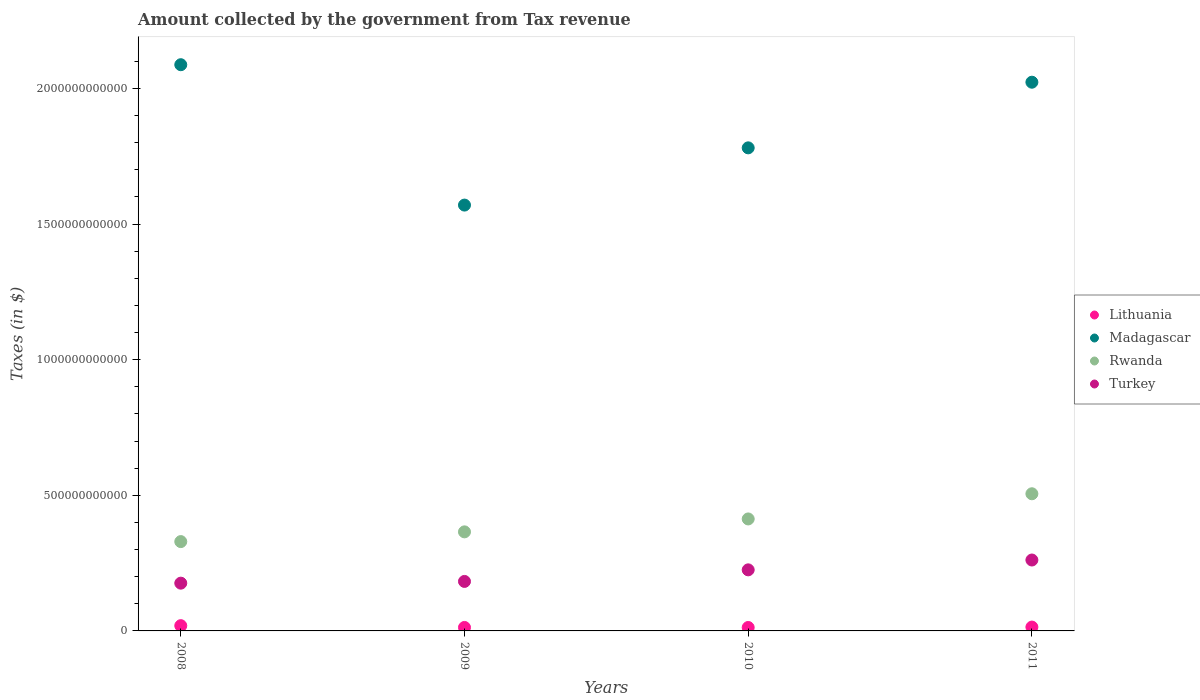How many different coloured dotlines are there?
Offer a very short reply. 4. Is the number of dotlines equal to the number of legend labels?
Provide a succinct answer. Yes. What is the amount collected by the government from tax revenue in Lithuania in 2009?
Provide a succinct answer. 1.28e+1. Across all years, what is the maximum amount collected by the government from tax revenue in Turkey?
Keep it short and to the point. 2.61e+11. Across all years, what is the minimum amount collected by the government from tax revenue in Madagascar?
Provide a succinct answer. 1.57e+12. In which year was the amount collected by the government from tax revenue in Turkey minimum?
Provide a succinct answer. 2008. What is the total amount collected by the government from tax revenue in Rwanda in the graph?
Your response must be concise. 1.61e+12. What is the difference between the amount collected by the government from tax revenue in Madagascar in 2009 and that in 2011?
Provide a short and direct response. -4.53e+11. What is the difference between the amount collected by the government from tax revenue in Turkey in 2011 and the amount collected by the government from tax revenue in Lithuania in 2008?
Make the answer very short. 2.42e+11. What is the average amount collected by the government from tax revenue in Madagascar per year?
Make the answer very short. 1.87e+12. In the year 2009, what is the difference between the amount collected by the government from tax revenue in Madagascar and amount collected by the government from tax revenue in Turkey?
Give a very brief answer. 1.39e+12. In how many years, is the amount collected by the government from tax revenue in Turkey greater than 1500000000000 $?
Offer a very short reply. 0. What is the ratio of the amount collected by the government from tax revenue in Turkey in 2010 to that in 2011?
Your answer should be very brief. 0.86. What is the difference between the highest and the second highest amount collected by the government from tax revenue in Madagascar?
Ensure brevity in your answer.  6.45e+1. What is the difference between the highest and the lowest amount collected by the government from tax revenue in Turkey?
Provide a short and direct response. 8.53e+1. In how many years, is the amount collected by the government from tax revenue in Turkey greater than the average amount collected by the government from tax revenue in Turkey taken over all years?
Give a very brief answer. 2. Is it the case that in every year, the sum of the amount collected by the government from tax revenue in Turkey and amount collected by the government from tax revenue in Lithuania  is greater than the sum of amount collected by the government from tax revenue in Madagascar and amount collected by the government from tax revenue in Rwanda?
Ensure brevity in your answer.  No. Is it the case that in every year, the sum of the amount collected by the government from tax revenue in Turkey and amount collected by the government from tax revenue in Rwanda  is greater than the amount collected by the government from tax revenue in Madagascar?
Your answer should be very brief. No. Does the amount collected by the government from tax revenue in Lithuania monotonically increase over the years?
Ensure brevity in your answer.  No. Is the amount collected by the government from tax revenue in Rwanda strictly less than the amount collected by the government from tax revenue in Madagascar over the years?
Provide a short and direct response. Yes. How many years are there in the graph?
Make the answer very short. 4. What is the difference between two consecutive major ticks on the Y-axis?
Offer a terse response. 5.00e+11. Does the graph contain any zero values?
Ensure brevity in your answer.  No. How many legend labels are there?
Provide a succinct answer. 4. What is the title of the graph?
Your answer should be very brief. Amount collected by the government from Tax revenue. What is the label or title of the Y-axis?
Offer a terse response. Taxes (in $). What is the Taxes (in $) in Lithuania in 2008?
Keep it short and to the point. 1.94e+1. What is the Taxes (in $) in Madagascar in 2008?
Offer a terse response. 2.09e+12. What is the Taxes (in $) in Rwanda in 2008?
Your response must be concise. 3.29e+11. What is the Taxes (in $) of Turkey in 2008?
Keep it short and to the point. 1.76e+11. What is the Taxes (in $) in Lithuania in 2009?
Your response must be concise. 1.28e+1. What is the Taxes (in $) in Madagascar in 2009?
Offer a terse response. 1.57e+12. What is the Taxes (in $) of Rwanda in 2009?
Ensure brevity in your answer.  3.65e+11. What is the Taxes (in $) of Turkey in 2009?
Your response must be concise. 1.82e+11. What is the Taxes (in $) in Lithuania in 2010?
Offer a very short reply. 1.26e+1. What is the Taxes (in $) of Madagascar in 2010?
Offer a very short reply. 1.78e+12. What is the Taxes (in $) of Rwanda in 2010?
Make the answer very short. 4.13e+11. What is the Taxes (in $) of Turkey in 2010?
Your answer should be compact. 2.25e+11. What is the Taxes (in $) in Lithuania in 2011?
Keep it short and to the point. 1.42e+1. What is the Taxes (in $) in Madagascar in 2011?
Offer a very short reply. 2.02e+12. What is the Taxes (in $) in Rwanda in 2011?
Provide a succinct answer. 5.06e+11. What is the Taxes (in $) of Turkey in 2011?
Give a very brief answer. 2.61e+11. Across all years, what is the maximum Taxes (in $) in Lithuania?
Offer a terse response. 1.94e+1. Across all years, what is the maximum Taxes (in $) in Madagascar?
Your response must be concise. 2.09e+12. Across all years, what is the maximum Taxes (in $) in Rwanda?
Your answer should be very brief. 5.06e+11. Across all years, what is the maximum Taxes (in $) of Turkey?
Ensure brevity in your answer.  2.61e+11. Across all years, what is the minimum Taxes (in $) of Lithuania?
Provide a succinct answer. 1.26e+1. Across all years, what is the minimum Taxes (in $) in Madagascar?
Your response must be concise. 1.57e+12. Across all years, what is the minimum Taxes (in $) in Rwanda?
Offer a very short reply. 3.29e+11. Across all years, what is the minimum Taxes (in $) in Turkey?
Your answer should be very brief. 1.76e+11. What is the total Taxes (in $) of Lithuania in the graph?
Provide a succinct answer. 5.90e+1. What is the total Taxes (in $) in Madagascar in the graph?
Your answer should be very brief. 7.46e+12. What is the total Taxes (in $) in Rwanda in the graph?
Offer a very short reply. 1.61e+12. What is the total Taxes (in $) in Turkey in the graph?
Your response must be concise. 8.45e+11. What is the difference between the Taxes (in $) of Lithuania in 2008 and that in 2009?
Offer a very short reply. 6.59e+09. What is the difference between the Taxes (in $) of Madagascar in 2008 and that in 2009?
Ensure brevity in your answer.  5.17e+11. What is the difference between the Taxes (in $) in Rwanda in 2008 and that in 2009?
Provide a succinct answer. -3.59e+1. What is the difference between the Taxes (in $) in Turkey in 2008 and that in 2009?
Your answer should be very brief. -6.43e+09. What is the difference between the Taxes (in $) in Lithuania in 2008 and that in 2010?
Keep it short and to the point. 6.74e+09. What is the difference between the Taxes (in $) in Madagascar in 2008 and that in 2010?
Give a very brief answer. 3.06e+11. What is the difference between the Taxes (in $) in Rwanda in 2008 and that in 2010?
Give a very brief answer. -8.35e+1. What is the difference between the Taxes (in $) of Turkey in 2008 and that in 2010?
Your answer should be compact. -4.91e+1. What is the difference between the Taxes (in $) in Lithuania in 2008 and that in 2011?
Provide a short and direct response. 5.20e+09. What is the difference between the Taxes (in $) of Madagascar in 2008 and that in 2011?
Offer a very short reply. 6.45e+1. What is the difference between the Taxes (in $) of Rwanda in 2008 and that in 2011?
Your response must be concise. -1.76e+11. What is the difference between the Taxes (in $) of Turkey in 2008 and that in 2011?
Give a very brief answer. -8.53e+1. What is the difference between the Taxes (in $) in Lithuania in 2009 and that in 2010?
Your response must be concise. 1.54e+08. What is the difference between the Taxes (in $) in Madagascar in 2009 and that in 2010?
Your answer should be very brief. -2.11e+11. What is the difference between the Taxes (in $) in Rwanda in 2009 and that in 2010?
Offer a terse response. -4.76e+1. What is the difference between the Taxes (in $) in Turkey in 2009 and that in 2010?
Provide a short and direct response. -4.26e+1. What is the difference between the Taxes (in $) of Lithuania in 2009 and that in 2011?
Offer a very short reply. -1.38e+09. What is the difference between the Taxes (in $) of Madagascar in 2009 and that in 2011?
Ensure brevity in your answer.  -4.53e+11. What is the difference between the Taxes (in $) of Rwanda in 2009 and that in 2011?
Keep it short and to the point. -1.40e+11. What is the difference between the Taxes (in $) of Turkey in 2009 and that in 2011?
Your answer should be very brief. -7.89e+1. What is the difference between the Taxes (in $) in Lithuania in 2010 and that in 2011?
Provide a succinct answer. -1.54e+09. What is the difference between the Taxes (in $) of Madagascar in 2010 and that in 2011?
Keep it short and to the point. -2.42e+11. What is the difference between the Taxes (in $) in Rwanda in 2010 and that in 2011?
Provide a succinct answer. -9.28e+1. What is the difference between the Taxes (in $) in Turkey in 2010 and that in 2011?
Provide a short and direct response. -3.63e+1. What is the difference between the Taxes (in $) of Lithuania in 2008 and the Taxes (in $) of Madagascar in 2009?
Offer a very short reply. -1.55e+12. What is the difference between the Taxes (in $) in Lithuania in 2008 and the Taxes (in $) in Rwanda in 2009?
Give a very brief answer. -3.46e+11. What is the difference between the Taxes (in $) in Lithuania in 2008 and the Taxes (in $) in Turkey in 2009?
Your answer should be very brief. -1.63e+11. What is the difference between the Taxes (in $) in Madagascar in 2008 and the Taxes (in $) in Rwanda in 2009?
Keep it short and to the point. 1.72e+12. What is the difference between the Taxes (in $) in Madagascar in 2008 and the Taxes (in $) in Turkey in 2009?
Your response must be concise. 1.90e+12. What is the difference between the Taxes (in $) of Rwanda in 2008 and the Taxes (in $) of Turkey in 2009?
Give a very brief answer. 1.47e+11. What is the difference between the Taxes (in $) of Lithuania in 2008 and the Taxes (in $) of Madagascar in 2010?
Ensure brevity in your answer.  -1.76e+12. What is the difference between the Taxes (in $) in Lithuania in 2008 and the Taxes (in $) in Rwanda in 2010?
Keep it short and to the point. -3.93e+11. What is the difference between the Taxes (in $) of Lithuania in 2008 and the Taxes (in $) of Turkey in 2010?
Keep it short and to the point. -2.06e+11. What is the difference between the Taxes (in $) of Madagascar in 2008 and the Taxes (in $) of Rwanda in 2010?
Provide a succinct answer. 1.67e+12. What is the difference between the Taxes (in $) of Madagascar in 2008 and the Taxes (in $) of Turkey in 2010?
Keep it short and to the point. 1.86e+12. What is the difference between the Taxes (in $) in Rwanda in 2008 and the Taxes (in $) in Turkey in 2010?
Provide a succinct answer. 1.04e+11. What is the difference between the Taxes (in $) in Lithuania in 2008 and the Taxes (in $) in Madagascar in 2011?
Offer a very short reply. -2.00e+12. What is the difference between the Taxes (in $) of Lithuania in 2008 and the Taxes (in $) of Rwanda in 2011?
Give a very brief answer. -4.86e+11. What is the difference between the Taxes (in $) of Lithuania in 2008 and the Taxes (in $) of Turkey in 2011?
Offer a terse response. -2.42e+11. What is the difference between the Taxes (in $) of Madagascar in 2008 and the Taxes (in $) of Rwanda in 2011?
Your response must be concise. 1.58e+12. What is the difference between the Taxes (in $) of Madagascar in 2008 and the Taxes (in $) of Turkey in 2011?
Provide a succinct answer. 1.83e+12. What is the difference between the Taxes (in $) in Rwanda in 2008 and the Taxes (in $) in Turkey in 2011?
Offer a very short reply. 6.79e+1. What is the difference between the Taxes (in $) of Lithuania in 2009 and the Taxes (in $) of Madagascar in 2010?
Your answer should be very brief. -1.77e+12. What is the difference between the Taxes (in $) in Lithuania in 2009 and the Taxes (in $) in Rwanda in 2010?
Provide a succinct answer. -4.00e+11. What is the difference between the Taxes (in $) of Lithuania in 2009 and the Taxes (in $) of Turkey in 2010?
Provide a succinct answer. -2.12e+11. What is the difference between the Taxes (in $) of Madagascar in 2009 and the Taxes (in $) of Rwanda in 2010?
Provide a short and direct response. 1.16e+12. What is the difference between the Taxes (in $) of Madagascar in 2009 and the Taxes (in $) of Turkey in 2010?
Provide a short and direct response. 1.34e+12. What is the difference between the Taxes (in $) in Rwanda in 2009 and the Taxes (in $) in Turkey in 2010?
Offer a terse response. 1.40e+11. What is the difference between the Taxes (in $) of Lithuania in 2009 and the Taxes (in $) of Madagascar in 2011?
Provide a succinct answer. -2.01e+12. What is the difference between the Taxes (in $) of Lithuania in 2009 and the Taxes (in $) of Rwanda in 2011?
Offer a very short reply. -4.93e+11. What is the difference between the Taxes (in $) in Lithuania in 2009 and the Taxes (in $) in Turkey in 2011?
Offer a very short reply. -2.49e+11. What is the difference between the Taxes (in $) of Madagascar in 2009 and the Taxes (in $) of Rwanda in 2011?
Your answer should be very brief. 1.06e+12. What is the difference between the Taxes (in $) of Madagascar in 2009 and the Taxes (in $) of Turkey in 2011?
Your answer should be compact. 1.31e+12. What is the difference between the Taxes (in $) of Rwanda in 2009 and the Taxes (in $) of Turkey in 2011?
Your answer should be compact. 1.04e+11. What is the difference between the Taxes (in $) of Lithuania in 2010 and the Taxes (in $) of Madagascar in 2011?
Your response must be concise. -2.01e+12. What is the difference between the Taxes (in $) in Lithuania in 2010 and the Taxes (in $) in Rwanda in 2011?
Keep it short and to the point. -4.93e+11. What is the difference between the Taxes (in $) in Lithuania in 2010 and the Taxes (in $) in Turkey in 2011?
Provide a succinct answer. -2.49e+11. What is the difference between the Taxes (in $) of Madagascar in 2010 and the Taxes (in $) of Rwanda in 2011?
Provide a succinct answer. 1.28e+12. What is the difference between the Taxes (in $) of Madagascar in 2010 and the Taxes (in $) of Turkey in 2011?
Offer a terse response. 1.52e+12. What is the difference between the Taxes (in $) in Rwanda in 2010 and the Taxes (in $) in Turkey in 2011?
Ensure brevity in your answer.  1.51e+11. What is the average Taxes (in $) in Lithuania per year?
Give a very brief answer. 1.47e+1. What is the average Taxes (in $) in Madagascar per year?
Keep it short and to the point. 1.87e+12. What is the average Taxes (in $) in Rwanda per year?
Provide a succinct answer. 4.03e+11. What is the average Taxes (in $) of Turkey per year?
Give a very brief answer. 2.11e+11. In the year 2008, what is the difference between the Taxes (in $) in Lithuania and Taxes (in $) in Madagascar?
Your response must be concise. -2.07e+12. In the year 2008, what is the difference between the Taxes (in $) of Lithuania and Taxes (in $) of Rwanda?
Make the answer very short. -3.10e+11. In the year 2008, what is the difference between the Taxes (in $) of Lithuania and Taxes (in $) of Turkey?
Provide a short and direct response. -1.57e+11. In the year 2008, what is the difference between the Taxes (in $) in Madagascar and Taxes (in $) in Rwanda?
Offer a terse response. 1.76e+12. In the year 2008, what is the difference between the Taxes (in $) in Madagascar and Taxes (in $) in Turkey?
Ensure brevity in your answer.  1.91e+12. In the year 2008, what is the difference between the Taxes (in $) of Rwanda and Taxes (in $) of Turkey?
Keep it short and to the point. 1.53e+11. In the year 2009, what is the difference between the Taxes (in $) in Lithuania and Taxes (in $) in Madagascar?
Provide a short and direct response. -1.56e+12. In the year 2009, what is the difference between the Taxes (in $) of Lithuania and Taxes (in $) of Rwanda?
Your answer should be compact. -3.52e+11. In the year 2009, what is the difference between the Taxes (in $) in Lithuania and Taxes (in $) in Turkey?
Offer a terse response. -1.70e+11. In the year 2009, what is the difference between the Taxes (in $) of Madagascar and Taxes (in $) of Rwanda?
Make the answer very short. 1.20e+12. In the year 2009, what is the difference between the Taxes (in $) of Madagascar and Taxes (in $) of Turkey?
Your response must be concise. 1.39e+12. In the year 2009, what is the difference between the Taxes (in $) of Rwanda and Taxes (in $) of Turkey?
Make the answer very short. 1.83e+11. In the year 2010, what is the difference between the Taxes (in $) in Lithuania and Taxes (in $) in Madagascar?
Provide a short and direct response. -1.77e+12. In the year 2010, what is the difference between the Taxes (in $) of Lithuania and Taxes (in $) of Rwanda?
Offer a very short reply. -4.00e+11. In the year 2010, what is the difference between the Taxes (in $) of Lithuania and Taxes (in $) of Turkey?
Keep it short and to the point. -2.12e+11. In the year 2010, what is the difference between the Taxes (in $) in Madagascar and Taxes (in $) in Rwanda?
Offer a very short reply. 1.37e+12. In the year 2010, what is the difference between the Taxes (in $) of Madagascar and Taxes (in $) of Turkey?
Keep it short and to the point. 1.56e+12. In the year 2010, what is the difference between the Taxes (in $) of Rwanda and Taxes (in $) of Turkey?
Your answer should be very brief. 1.88e+11. In the year 2011, what is the difference between the Taxes (in $) of Lithuania and Taxes (in $) of Madagascar?
Your response must be concise. -2.01e+12. In the year 2011, what is the difference between the Taxes (in $) of Lithuania and Taxes (in $) of Rwanda?
Keep it short and to the point. -4.91e+11. In the year 2011, what is the difference between the Taxes (in $) of Lithuania and Taxes (in $) of Turkey?
Keep it short and to the point. -2.47e+11. In the year 2011, what is the difference between the Taxes (in $) of Madagascar and Taxes (in $) of Rwanda?
Your answer should be very brief. 1.52e+12. In the year 2011, what is the difference between the Taxes (in $) in Madagascar and Taxes (in $) in Turkey?
Keep it short and to the point. 1.76e+12. In the year 2011, what is the difference between the Taxes (in $) of Rwanda and Taxes (in $) of Turkey?
Your answer should be compact. 2.44e+11. What is the ratio of the Taxes (in $) of Lithuania in 2008 to that in 2009?
Your answer should be compact. 1.51. What is the ratio of the Taxes (in $) of Madagascar in 2008 to that in 2009?
Ensure brevity in your answer.  1.33. What is the ratio of the Taxes (in $) in Rwanda in 2008 to that in 2009?
Provide a succinct answer. 0.9. What is the ratio of the Taxes (in $) in Turkey in 2008 to that in 2009?
Keep it short and to the point. 0.96. What is the ratio of the Taxes (in $) in Lithuania in 2008 to that in 2010?
Your answer should be compact. 1.53. What is the ratio of the Taxes (in $) of Madagascar in 2008 to that in 2010?
Your answer should be compact. 1.17. What is the ratio of the Taxes (in $) of Rwanda in 2008 to that in 2010?
Your answer should be very brief. 0.8. What is the ratio of the Taxes (in $) in Turkey in 2008 to that in 2010?
Offer a terse response. 0.78. What is the ratio of the Taxes (in $) in Lithuania in 2008 to that in 2011?
Keep it short and to the point. 1.37. What is the ratio of the Taxes (in $) of Madagascar in 2008 to that in 2011?
Your response must be concise. 1.03. What is the ratio of the Taxes (in $) in Rwanda in 2008 to that in 2011?
Make the answer very short. 0.65. What is the ratio of the Taxes (in $) in Turkey in 2008 to that in 2011?
Your response must be concise. 0.67. What is the ratio of the Taxes (in $) of Lithuania in 2009 to that in 2010?
Your response must be concise. 1.01. What is the ratio of the Taxes (in $) of Madagascar in 2009 to that in 2010?
Make the answer very short. 0.88. What is the ratio of the Taxes (in $) of Rwanda in 2009 to that in 2010?
Your response must be concise. 0.88. What is the ratio of the Taxes (in $) in Turkey in 2009 to that in 2010?
Offer a terse response. 0.81. What is the ratio of the Taxes (in $) of Lithuania in 2009 to that in 2011?
Offer a very short reply. 0.9. What is the ratio of the Taxes (in $) in Madagascar in 2009 to that in 2011?
Offer a terse response. 0.78. What is the ratio of the Taxes (in $) in Rwanda in 2009 to that in 2011?
Ensure brevity in your answer.  0.72. What is the ratio of the Taxes (in $) of Turkey in 2009 to that in 2011?
Your answer should be very brief. 0.7. What is the ratio of the Taxes (in $) in Lithuania in 2010 to that in 2011?
Provide a short and direct response. 0.89. What is the ratio of the Taxes (in $) in Madagascar in 2010 to that in 2011?
Your answer should be compact. 0.88. What is the ratio of the Taxes (in $) in Rwanda in 2010 to that in 2011?
Offer a terse response. 0.82. What is the ratio of the Taxes (in $) of Turkey in 2010 to that in 2011?
Ensure brevity in your answer.  0.86. What is the difference between the highest and the second highest Taxes (in $) in Lithuania?
Your answer should be very brief. 5.20e+09. What is the difference between the highest and the second highest Taxes (in $) in Madagascar?
Keep it short and to the point. 6.45e+1. What is the difference between the highest and the second highest Taxes (in $) in Rwanda?
Give a very brief answer. 9.28e+1. What is the difference between the highest and the second highest Taxes (in $) of Turkey?
Keep it short and to the point. 3.63e+1. What is the difference between the highest and the lowest Taxes (in $) in Lithuania?
Provide a short and direct response. 6.74e+09. What is the difference between the highest and the lowest Taxes (in $) in Madagascar?
Give a very brief answer. 5.17e+11. What is the difference between the highest and the lowest Taxes (in $) in Rwanda?
Keep it short and to the point. 1.76e+11. What is the difference between the highest and the lowest Taxes (in $) of Turkey?
Your answer should be compact. 8.53e+1. 